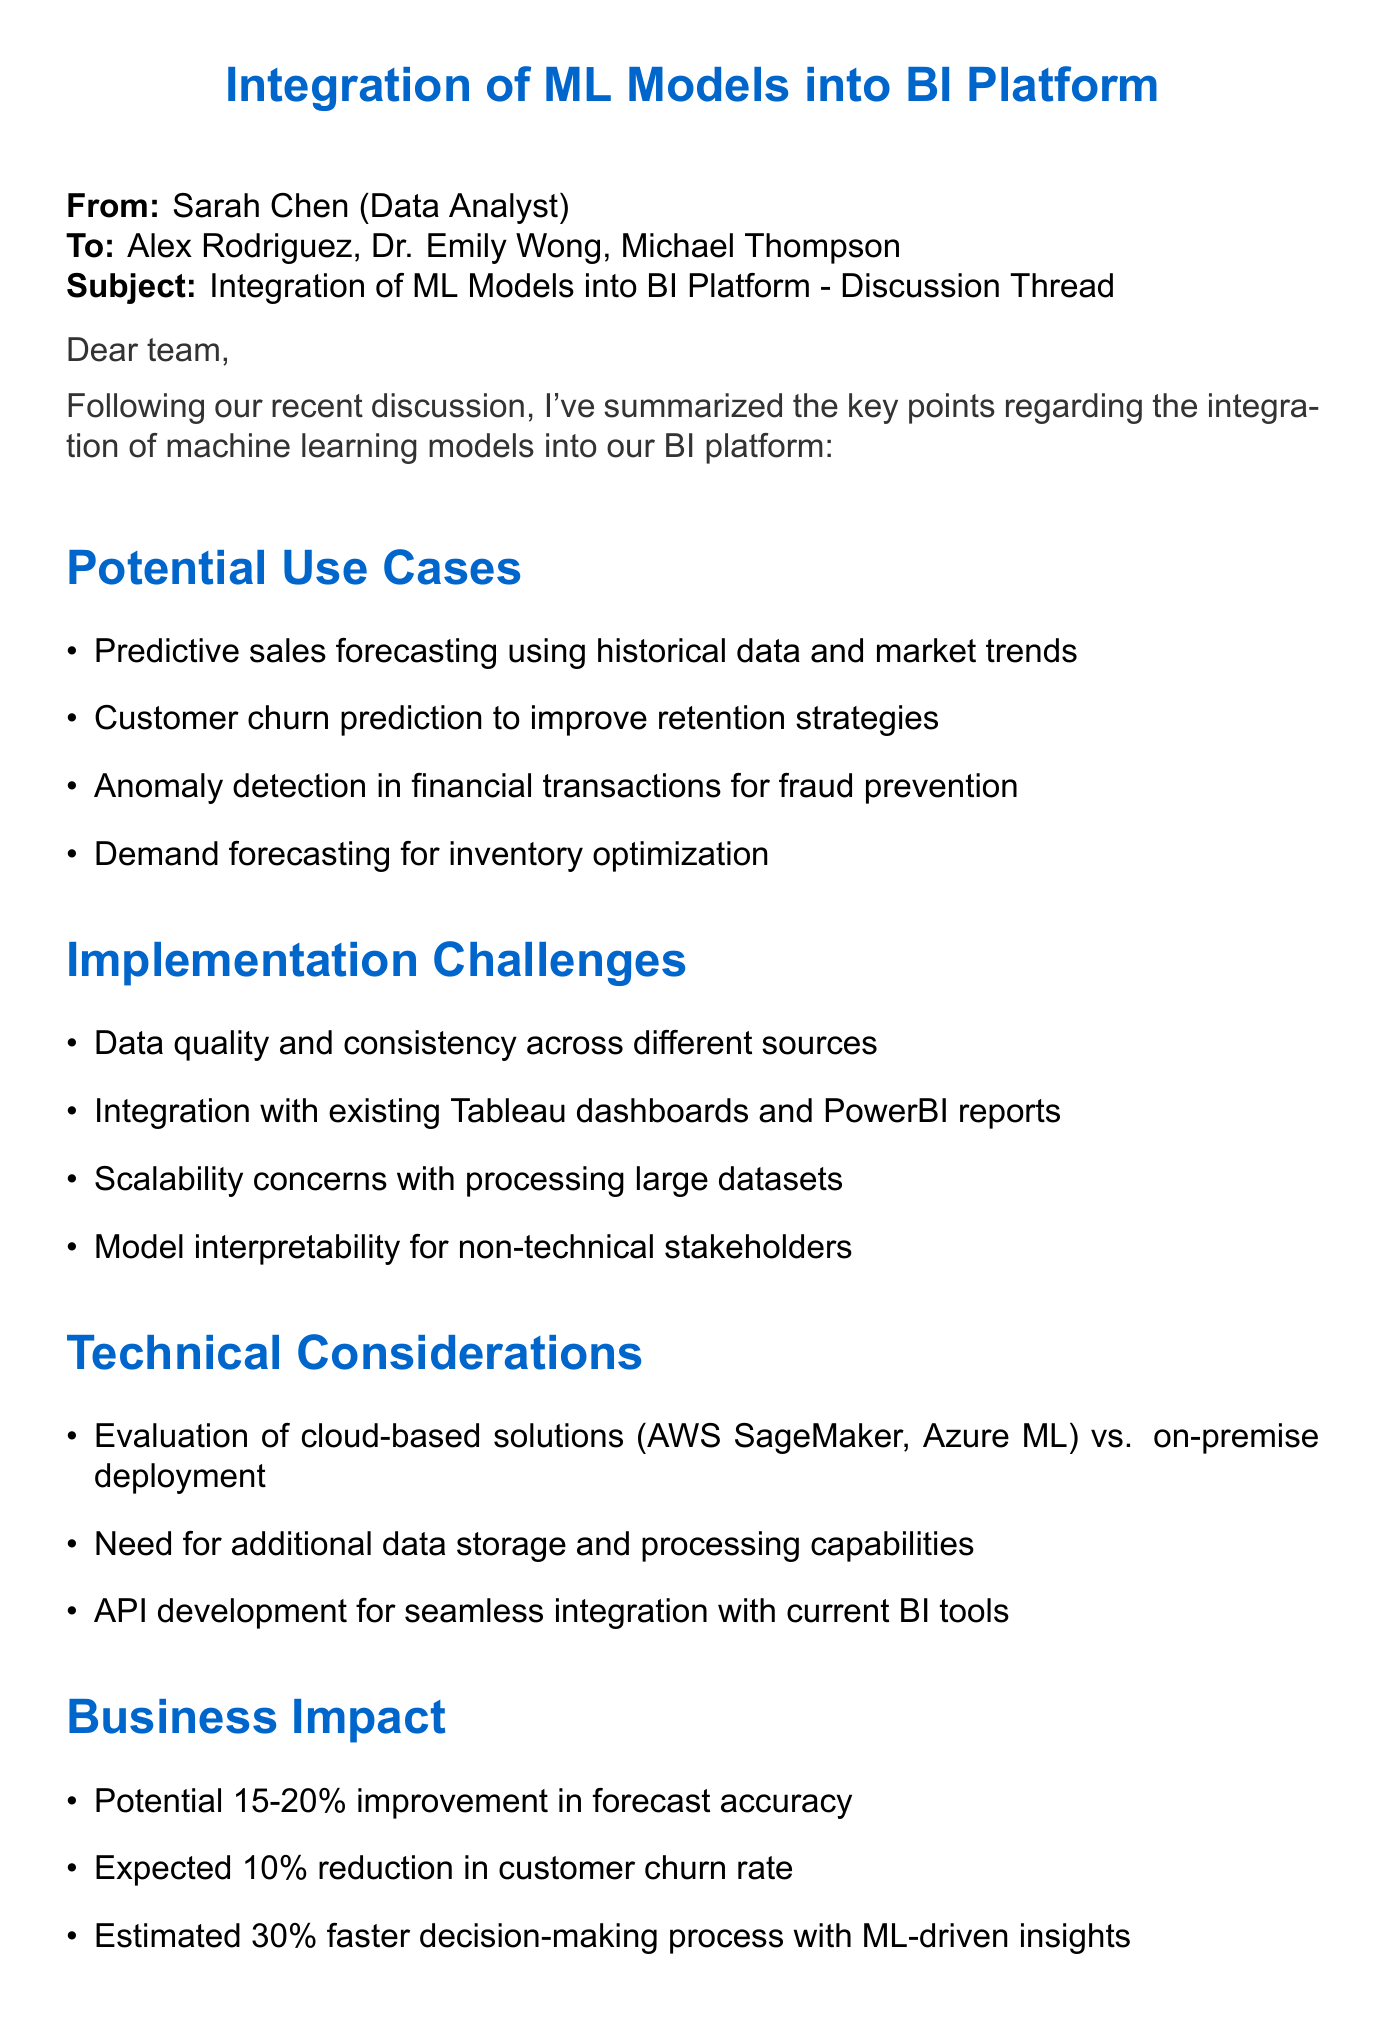What are the potential use cases for machine learning models? The document lists four specific potential use cases for machine learning models in the BI platform.
Answer: Predictive sales forecasting, customer churn prediction, anomaly detection, demand forecasting Who summarized the key points of the discussion? The email indicates that the summary of key points was provided by Sarah Chen.
Answer: Sarah Chen What is the expected reduction in customer churn rate? The document states the expected reduction percentage related to customer churn as a specific number.
Answer: 10 percent What are two implementation challenges mentioned? The summary includes a list of challenges. Two specific examples can be derived from that list of implementation challenges.
Answer: Data quality, integration with existing dashboards What is one technical consideration for the machine learning model integration? The email identifies three specific technical considerations regarding integration. One of them can be referenced directly from the list.
Answer: API development What is the potential improvement in forecast accuracy? The document provides an estimate related to forecast accuracy, which is a key metric for performance evaluation in the business context.
Answer: 15-20 percent What are the next steps after the discussion? The email outlines four specific next steps as an action plan post-discussion. One of these can be directly referenced.
Answer: Form a cross-functional team What is the role of Dr. Emily Wong in this discussion? The email indicates the specific role of each participant, and by context, Dr. Emily Wong's expertise is related to machine learning.
Answer: Machine Learning Specialist 